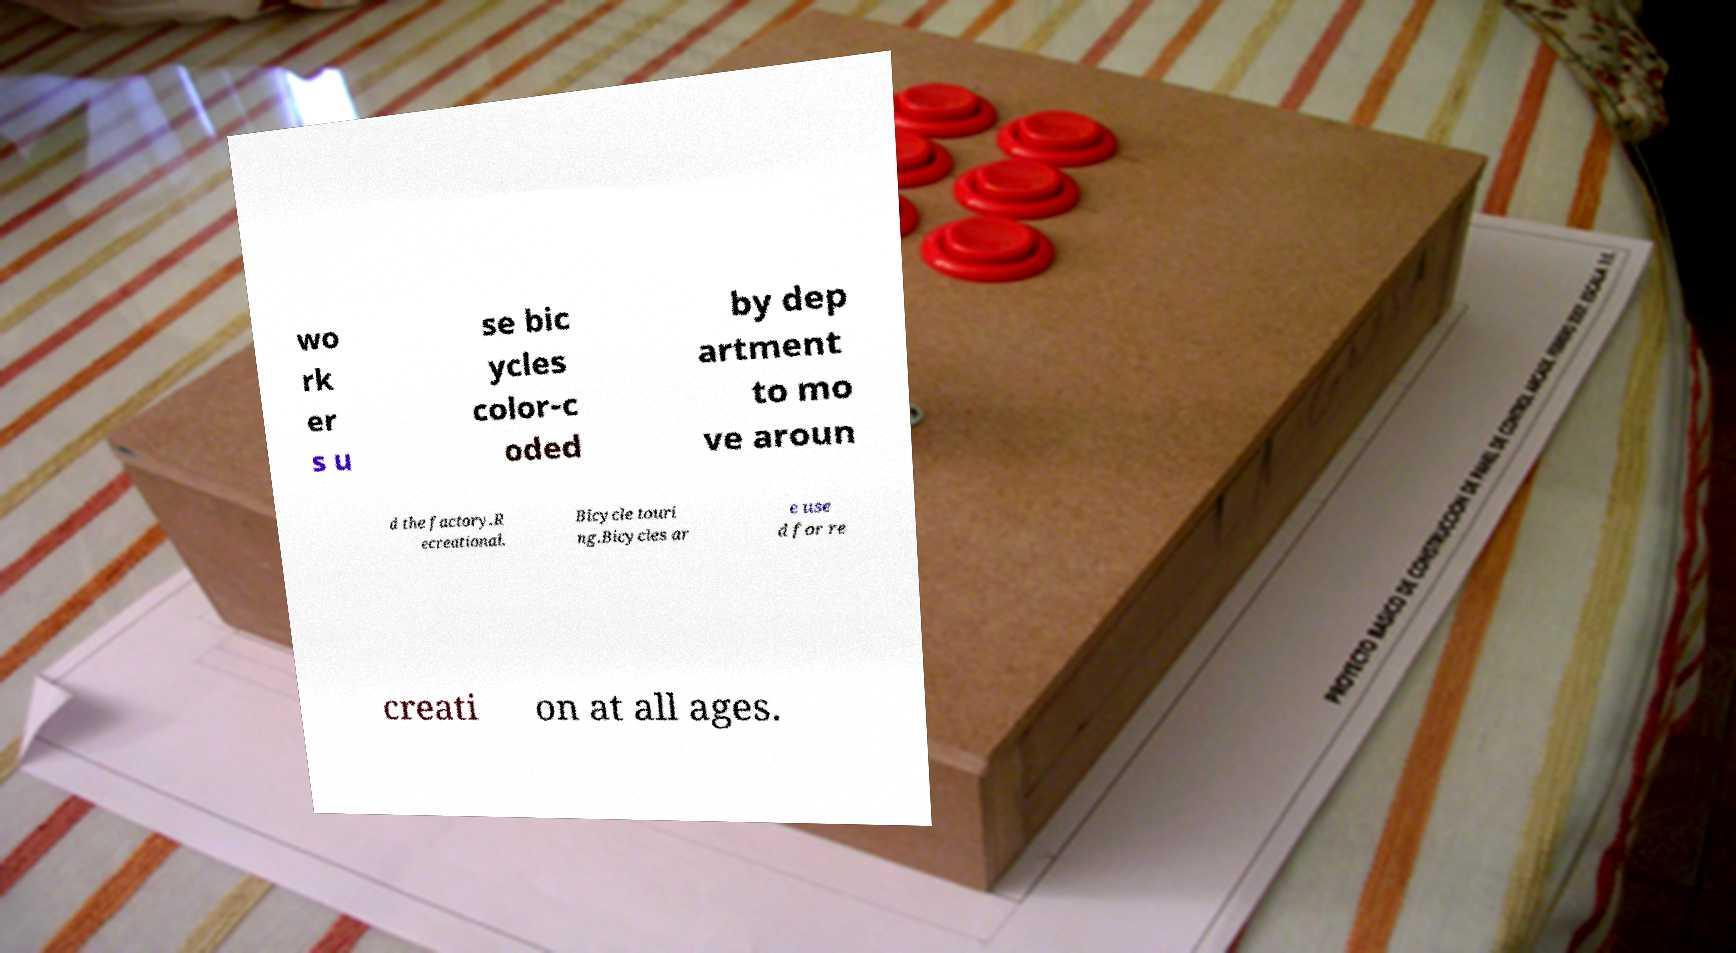Please read and relay the text visible in this image. What does it say? wo rk er s u se bic ycles color-c oded by dep artment to mo ve aroun d the factory.R ecreational. Bicycle touri ng.Bicycles ar e use d for re creati on at all ages. 